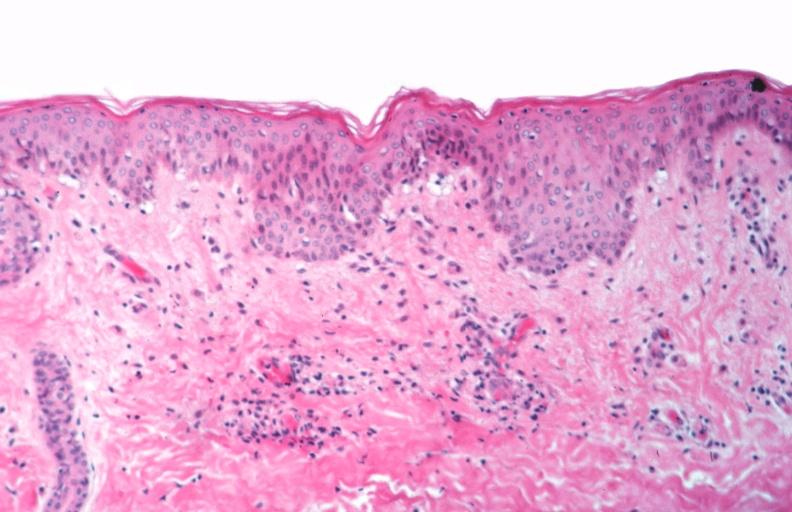does sebaceous cyst show skin?
Answer the question using a single word or phrase. No 